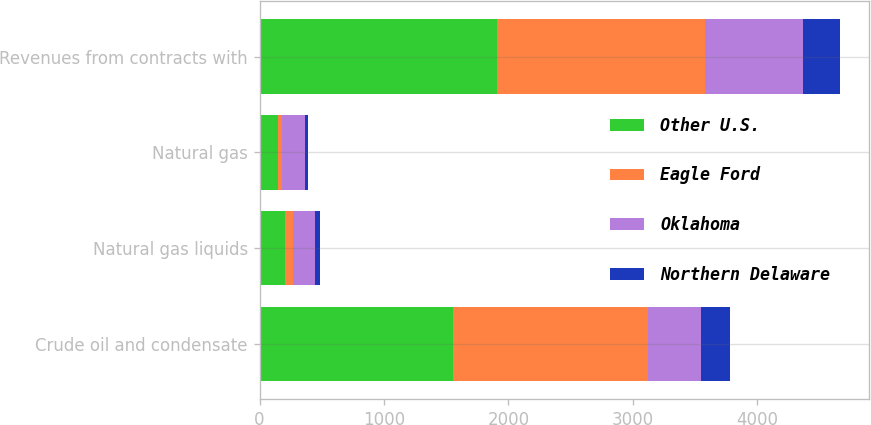Convert chart. <chart><loc_0><loc_0><loc_500><loc_500><stacked_bar_chart><ecel><fcel>Crude oil and condensate<fcel>Natural gas liquids<fcel>Natural gas<fcel>Revenues from contracts with<nl><fcel>Other U.S.<fcel>1554<fcel>205<fcel>145<fcel>1912<nl><fcel>Eagle Ford<fcel>1568<fcel>62<fcel>38<fcel>1668<nl><fcel>Oklahoma<fcel>426<fcel>181<fcel>184<fcel>791<nl><fcel>Northern Delaware<fcel>235<fcel>38<fcel>20<fcel>293<nl></chart> 